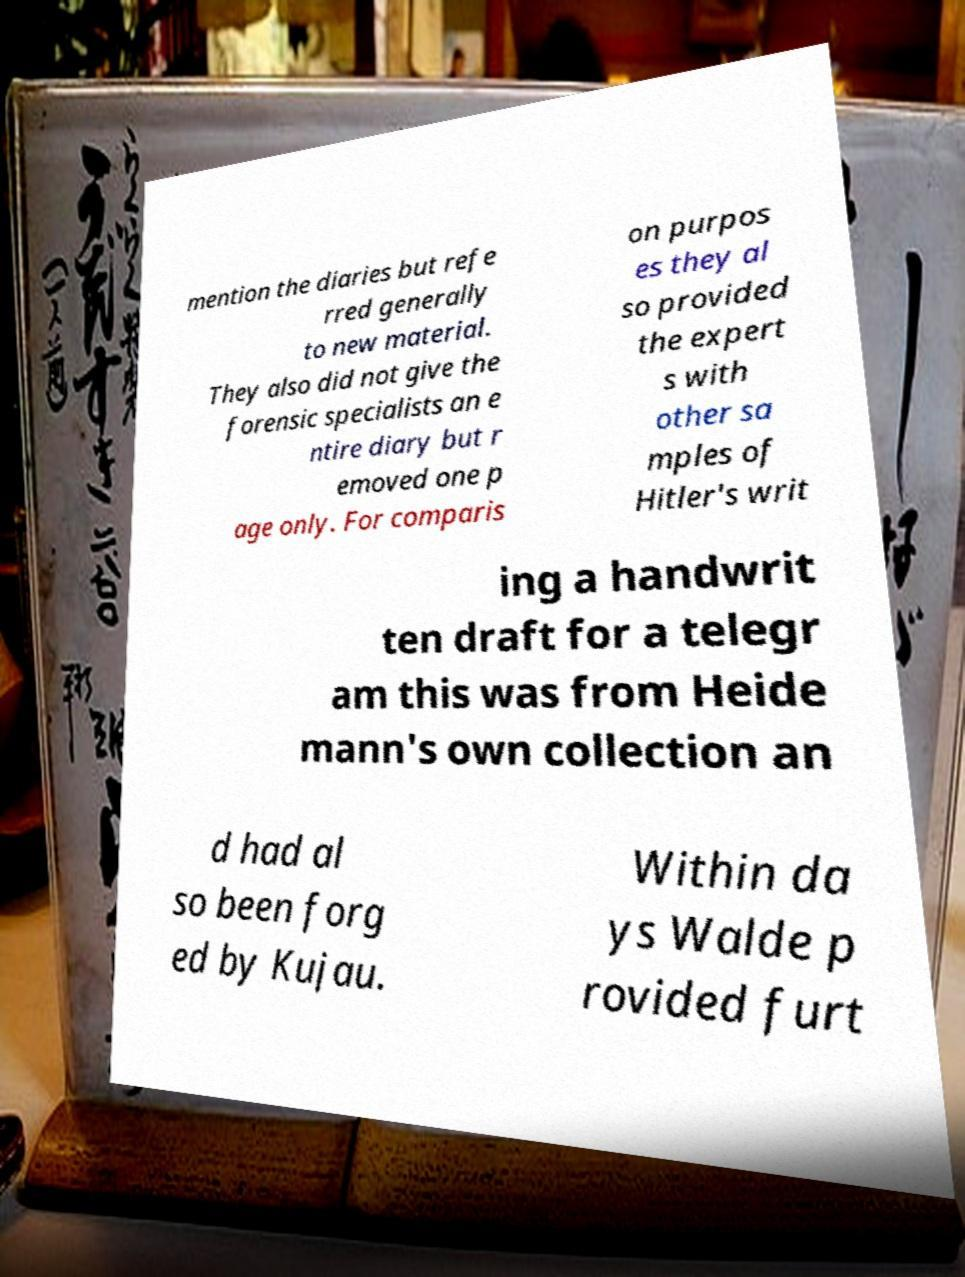I need the written content from this picture converted into text. Can you do that? mention the diaries but refe rred generally to new material. They also did not give the forensic specialists an e ntire diary but r emoved one p age only. For comparis on purpos es they al so provided the expert s with other sa mples of Hitler's writ ing a handwrit ten draft for a telegr am this was from Heide mann's own collection an d had al so been forg ed by Kujau. Within da ys Walde p rovided furt 